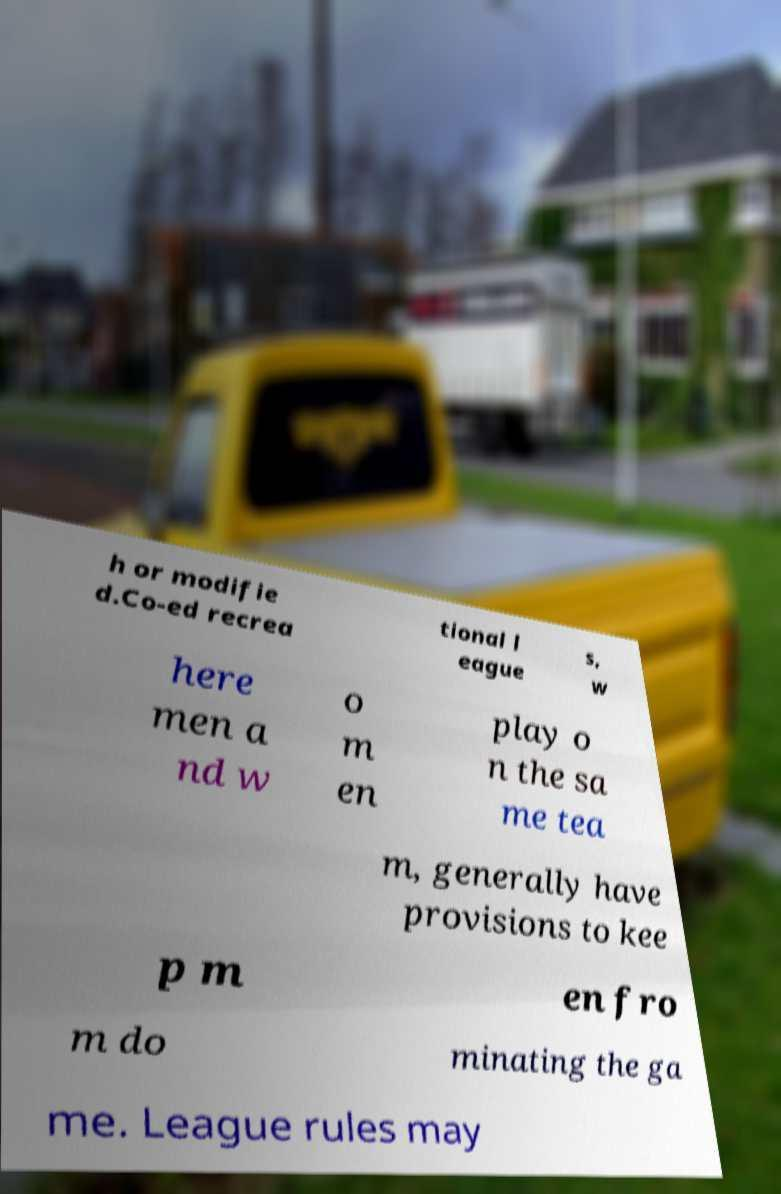Please read and relay the text visible in this image. What does it say? h or modifie d.Co-ed recrea tional l eague s, w here men a nd w o m en play o n the sa me tea m, generally have provisions to kee p m en fro m do minating the ga me. League rules may 